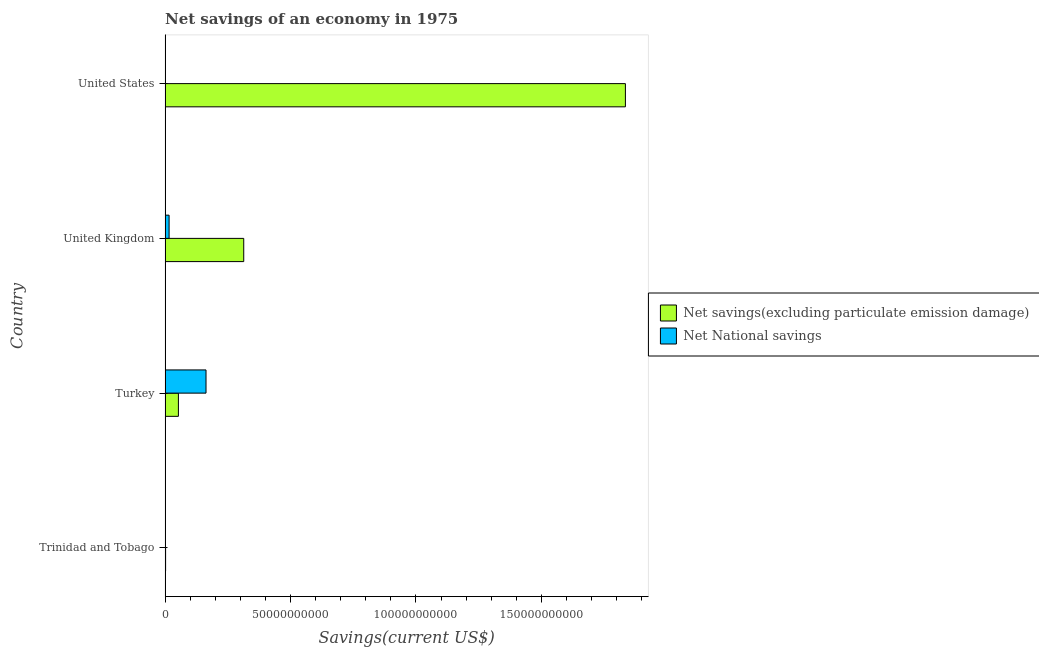How many different coloured bars are there?
Provide a succinct answer. 2. Are the number of bars per tick equal to the number of legend labels?
Keep it short and to the point. No. Are the number of bars on each tick of the Y-axis equal?
Ensure brevity in your answer.  No. What is the label of the 3rd group of bars from the top?
Provide a short and direct response. Turkey. What is the net savings(excluding particulate emission damage) in Trinidad and Tobago?
Provide a short and direct response. 2.00e+08. Across all countries, what is the maximum net savings(excluding particulate emission damage)?
Make the answer very short. 1.83e+11. Across all countries, what is the minimum net national savings?
Offer a very short reply. 0. In which country was the net national savings maximum?
Your response must be concise. Turkey. What is the total net national savings in the graph?
Ensure brevity in your answer.  1.80e+1. What is the difference between the net savings(excluding particulate emission damage) in Trinidad and Tobago and that in United States?
Provide a short and direct response. -1.83e+11. What is the difference between the net national savings in United Kingdom and the net savings(excluding particulate emission damage) in United States?
Give a very brief answer. -1.82e+11. What is the average net national savings per country?
Offer a very short reply. 4.51e+09. What is the difference between the net national savings and net savings(excluding particulate emission damage) in Turkey?
Keep it short and to the point. 1.10e+1. What is the ratio of the net savings(excluding particulate emission damage) in Trinidad and Tobago to that in United Kingdom?
Ensure brevity in your answer.  0.01. What is the difference between the highest and the second highest net national savings?
Your response must be concise. 1.47e+1. What is the difference between the highest and the lowest net national savings?
Keep it short and to the point. 1.63e+1. Is the sum of the net national savings in United Kingdom and United States greater than the maximum net savings(excluding particulate emission damage) across all countries?
Make the answer very short. No. How many bars are there?
Your response must be concise. 7. Does the graph contain any zero values?
Offer a terse response. Yes. How many legend labels are there?
Ensure brevity in your answer.  2. How are the legend labels stacked?
Ensure brevity in your answer.  Vertical. What is the title of the graph?
Give a very brief answer. Net savings of an economy in 1975. Does "Young" appear as one of the legend labels in the graph?
Give a very brief answer. No. What is the label or title of the X-axis?
Your answer should be very brief. Savings(current US$). What is the label or title of the Y-axis?
Ensure brevity in your answer.  Country. What is the Savings(current US$) of Net savings(excluding particulate emission damage) in Trinidad and Tobago?
Provide a succinct answer. 2.00e+08. What is the Savings(current US$) of Net National savings in Trinidad and Tobago?
Offer a very short reply. 0. What is the Savings(current US$) in Net savings(excluding particulate emission damage) in Turkey?
Give a very brief answer. 5.31e+09. What is the Savings(current US$) in Net National savings in Turkey?
Your response must be concise. 1.63e+1. What is the Savings(current US$) of Net savings(excluding particulate emission damage) in United Kingdom?
Offer a terse response. 3.13e+1. What is the Savings(current US$) of Net National savings in United Kingdom?
Keep it short and to the point. 1.60e+09. What is the Savings(current US$) of Net savings(excluding particulate emission damage) in United States?
Make the answer very short. 1.83e+11. What is the Savings(current US$) of Net National savings in United States?
Keep it short and to the point. 1.14e+08. Across all countries, what is the maximum Savings(current US$) in Net savings(excluding particulate emission damage)?
Provide a succinct answer. 1.83e+11. Across all countries, what is the maximum Savings(current US$) of Net National savings?
Give a very brief answer. 1.63e+1. Across all countries, what is the minimum Savings(current US$) in Net savings(excluding particulate emission damage)?
Give a very brief answer. 2.00e+08. Across all countries, what is the minimum Savings(current US$) in Net National savings?
Ensure brevity in your answer.  0. What is the total Savings(current US$) of Net savings(excluding particulate emission damage) in the graph?
Your answer should be very brief. 2.20e+11. What is the total Savings(current US$) in Net National savings in the graph?
Your answer should be very brief. 1.80e+1. What is the difference between the Savings(current US$) of Net savings(excluding particulate emission damage) in Trinidad and Tobago and that in Turkey?
Your answer should be compact. -5.11e+09. What is the difference between the Savings(current US$) of Net savings(excluding particulate emission damage) in Trinidad and Tobago and that in United Kingdom?
Ensure brevity in your answer.  -3.11e+1. What is the difference between the Savings(current US$) in Net savings(excluding particulate emission damage) in Trinidad and Tobago and that in United States?
Offer a very short reply. -1.83e+11. What is the difference between the Savings(current US$) in Net savings(excluding particulate emission damage) in Turkey and that in United Kingdom?
Give a very brief answer. -2.60e+1. What is the difference between the Savings(current US$) of Net National savings in Turkey and that in United Kingdom?
Your answer should be compact. 1.47e+1. What is the difference between the Savings(current US$) of Net savings(excluding particulate emission damage) in Turkey and that in United States?
Provide a short and direct response. -1.78e+11. What is the difference between the Savings(current US$) of Net National savings in Turkey and that in United States?
Give a very brief answer. 1.62e+1. What is the difference between the Savings(current US$) in Net savings(excluding particulate emission damage) in United Kingdom and that in United States?
Offer a very short reply. -1.52e+11. What is the difference between the Savings(current US$) in Net National savings in United Kingdom and that in United States?
Keep it short and to the point. 1.48e+09. What is the difference between the Savings(current US$) of Net savings(excluding particulate emission damage) in Trinidad and Tobago and the Savings(current US$) of Net National savings in Turkey?
Your answer should be compact. -1.61e+1. What is the difference between the Savings(current US$) in Net savings(excluding particulate emission damage) in Trinidad and Tobago and the Savings(current US$) in Net National savings in United Kingdom?
Keep it short and to the point. -1.39e+09. What is the difference between the Savings(current US$) in Net savings(excluding particulate emission damage) in Trinidad and Tobago and the Savings(current US$) in Net National savings in United States?
Offer a terse response. 8.67e+07. What is the difference between the Savings(current US$) in Net savings(excluding particulate emission damage) in Turkey and the Savings(current US$) in Net National savings in United Kingdom?
Provide a succinct answer. 3.71e+09. What is the difference between the Savings(current US$) of Net savings(excluding particulate emission damage) in Turkey and the Savings(current US$) of Net National savings in United States?
Ensure brevity in your answer.  5.19e+09. What is the difference between the Savings(current US$) in Net savings(excluding particulate emission damage) in United Kingdom and the Savings(current US$) in Net National savings in United States?
Offer a very short reply. 3.12e+1. What is the average Savings(current US$) in Net savings(excluding particulate emission damage) per country?
Your answer should be compact. 5.51e+1. What is the average Savings(current US$) of Net National savings per country?
Offer a terse response. 4.51e+09. What is the difference between the Savings(current US$) of Net savings(excluding particulate emission damage) and Savings(current US$) of Net National savings in Turkey?
Make the answer very short. -1.10e+1. What is the difference between the Savings(current US$) in Net savings(excluding particulate emission damage) and Savings(current US$) in Net National savings in United Kingdom?
Make the answer very short. 2.97e+1. What is the difference between the Savings(current US$) in Net savings(excluding particulate emission damage) and Savings(current US$) in Net National savings in United States?
Offer a terse response. 1.83e+11. What is the ratio of the Savings(current US$) of Net savings(excluding particulate emission damage) in Trinidad and Tobago to that in Turkey?
Offer a very short reply. 0.04. What is the ratio of the Savings(current US$) in Net savings(excluding particulate emission damage) in Trinidad and Tobago to that in United Kingdom?
Keep it short and to the point. 0.01. What is the ratio of the Savings(current US$) of Net savings(excluding particulate emission damage) in Trinidad and Tobago to that in United States?
Make the answer very short. 0. What is the ratio of the Savings(current US$) of Net savings(excluding particulate emission damage) in Turkey to that in United Kingdom?
Ensure brevity in your answer.  0.17. What is the ratio of the Savings(current US$) in Net National savings in Turkey to that in United Kingdom?
Keep it short and to the point. 10.22. What is the ratio of the Savings(current US$) in Net savings(excluding particulate emission damage) in Turkey to that in United States?
Provide a short and direct response. 0.03. What is the ratio of the Savings(current US$) of Net National savings in Turkey to that in United States?
Give a very brief answer. 143.42. What is the ratio of the Savings(current US$) of Net savings(excluding particulate emission damage) in United Kingdom to that in United States?
Your answer should be compact. 0.17. What is the ratio of the Savings(current US$) of Net National savings in United Kingdom to that in United States?
Your answer should be compact. 14.03. What is the difference between the highest and the second highest Savings(current US$) in Net savings(excluding particulate emission damage)?
Offer a very short reply. 1.52e+11. What is the difference between the highest and the second highest Savings(current US$) of Net National savings?
Provide a short and direct response. 1.47e+1. What is the difference between the highest and the lowest Savings(current US$) in Net savings(excluding particulate emission damage)?
Offer a terse response. 1.83e+11. What is the difference between the highest and the lowest Savings(current US$) in Net National savings?
Ensure brevity in your answer.  1.63e+1. 